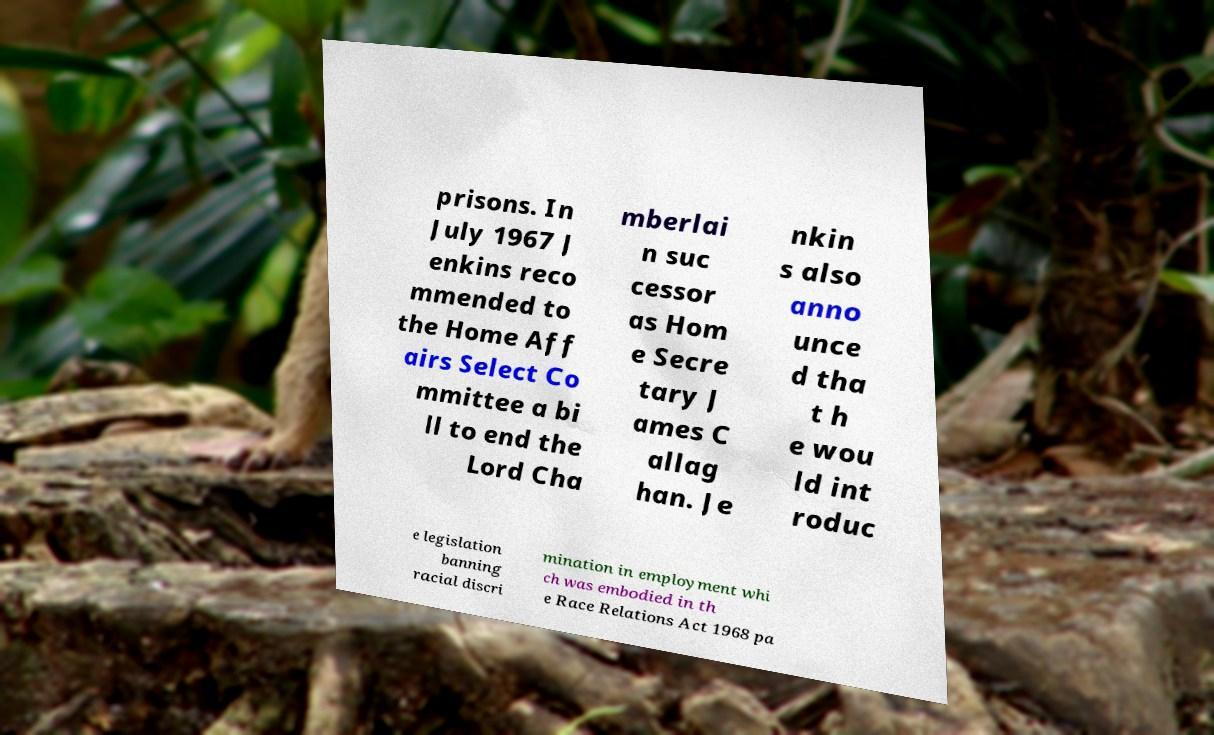What messages or text are displayed in this image? I need them in a readable, typed format. prisons. In July 1967 J enkins reco mmended to the Home Aff airs Select Co mmittee a bi ll to end the Lord Cha mberlai n suc cessor as Hom e Secre tary J ames C allag han. Je nkin s also anno unce d tha t h e wou ld int roduc e legislation banning racial discri mination in employment whi ch was embodied in th e Race Relations Act 1968 pa 